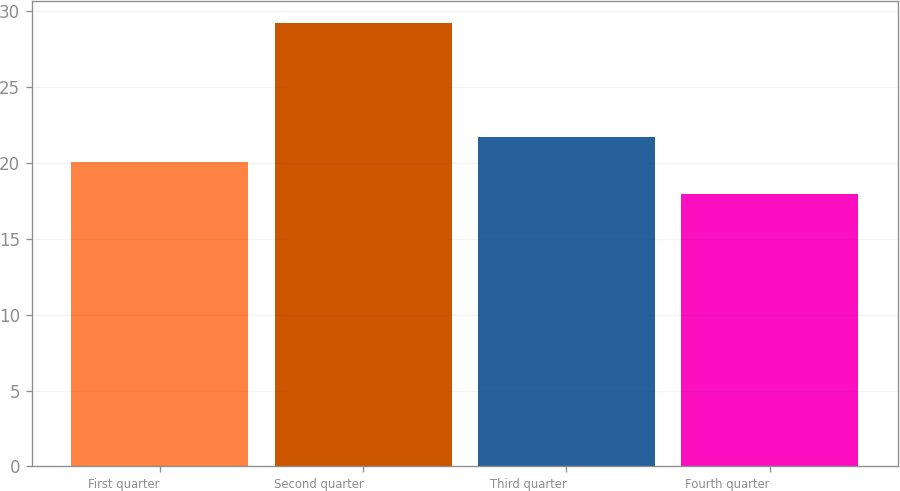<chart> <loc_0><loc_0><loc_500><loc_500><bar_chart><fcel>First quarter<fcel>Second quarter<fcel>Third quarter<fcel>Fourth quarter<nl><fcel>20.08<fcel>29.19<fcel>21.7<fcel>17.96<nl></chart> 